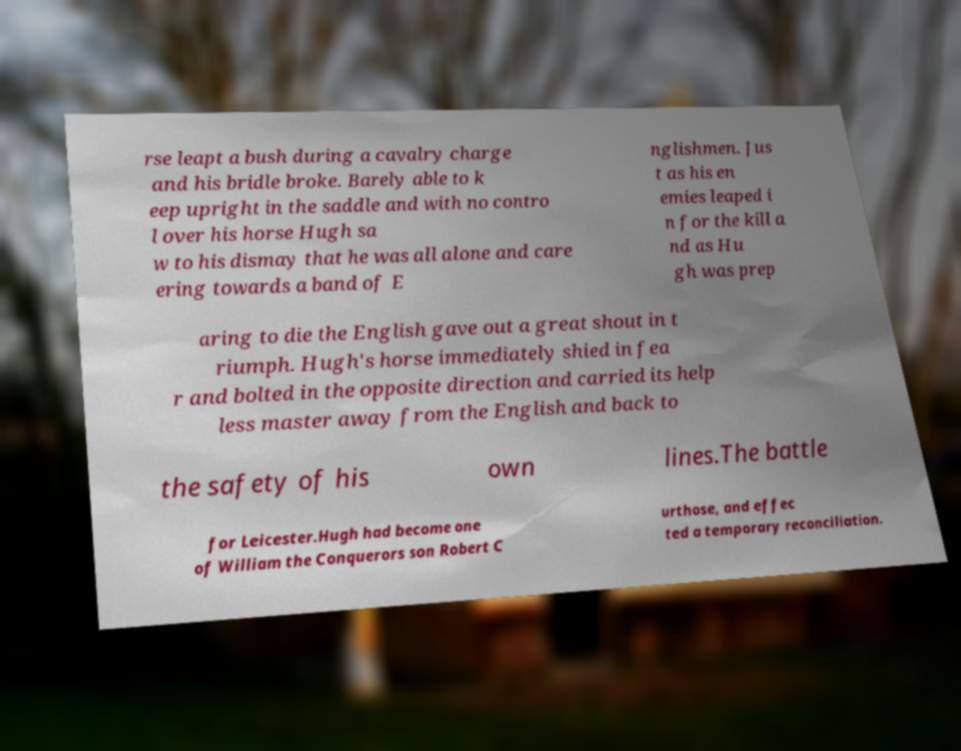Could you extract and type out the text from this image? rse leapt a bush during a cavalry charge and his bridle broke. Barely able to k eep upright in the saddle and with no contro l over his horse Hugh sa w to his dismay that he was all alone and care ering towards a band of E nglishmen. Jus t as his en emies leaped i n for the kill a nd as Hu gh was prep aring to die the English gave out a great shout in t riumph. Hugh's horse immediately shied in fea r and bolted in the opposite direction and carried its help less master away from the English and back to the safety of his own lines.The battle for Leicester.Hugh had become one of William the Conquerors son Robert C urthose, and effec ted a temporary reconciliation. 